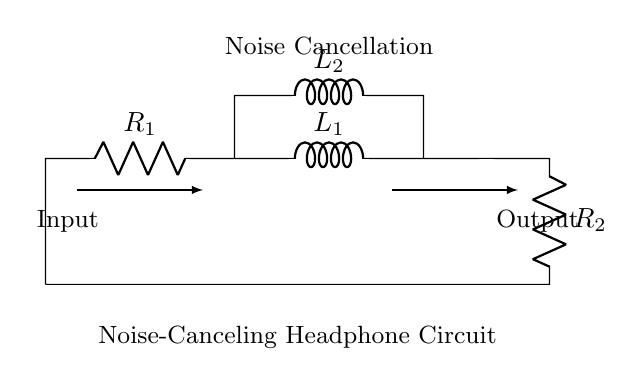What is the total number of resistors in the circuit? There are two resistors labeled as R1 and R2 in the circuit.
Answer: 2 What do L1 and L2 represent in the circuit? L1 and L2 are inductors, which are components that store energy in a magnetic field when electrical current flows through them.
Answer: Inductors What is the function of the Noise Cancellation label? The Noise Cancellation label indicates the specific part of the circuit that serves the purpose of reducing unwanted ambient sounds, which enhances audio quality.
Answer: Reducing ambient sounds What type of circuit configuration is used for R1 and R2? R1 and R2 are in series with the inductors L1 and L2, as they are connected end to end without any branching.
Answer: Series How many components are used in total? The total components are made up of 2 resistors and 2 inductors, giving a total of 4 components.
Answer: 4 What would happen if the resistance value of R1 is increased? Increasing R1 lowers the current through the circuit due to Ohm’s Law, which could affect the overall performance of the noise canceling function.
Answer: Lower current 